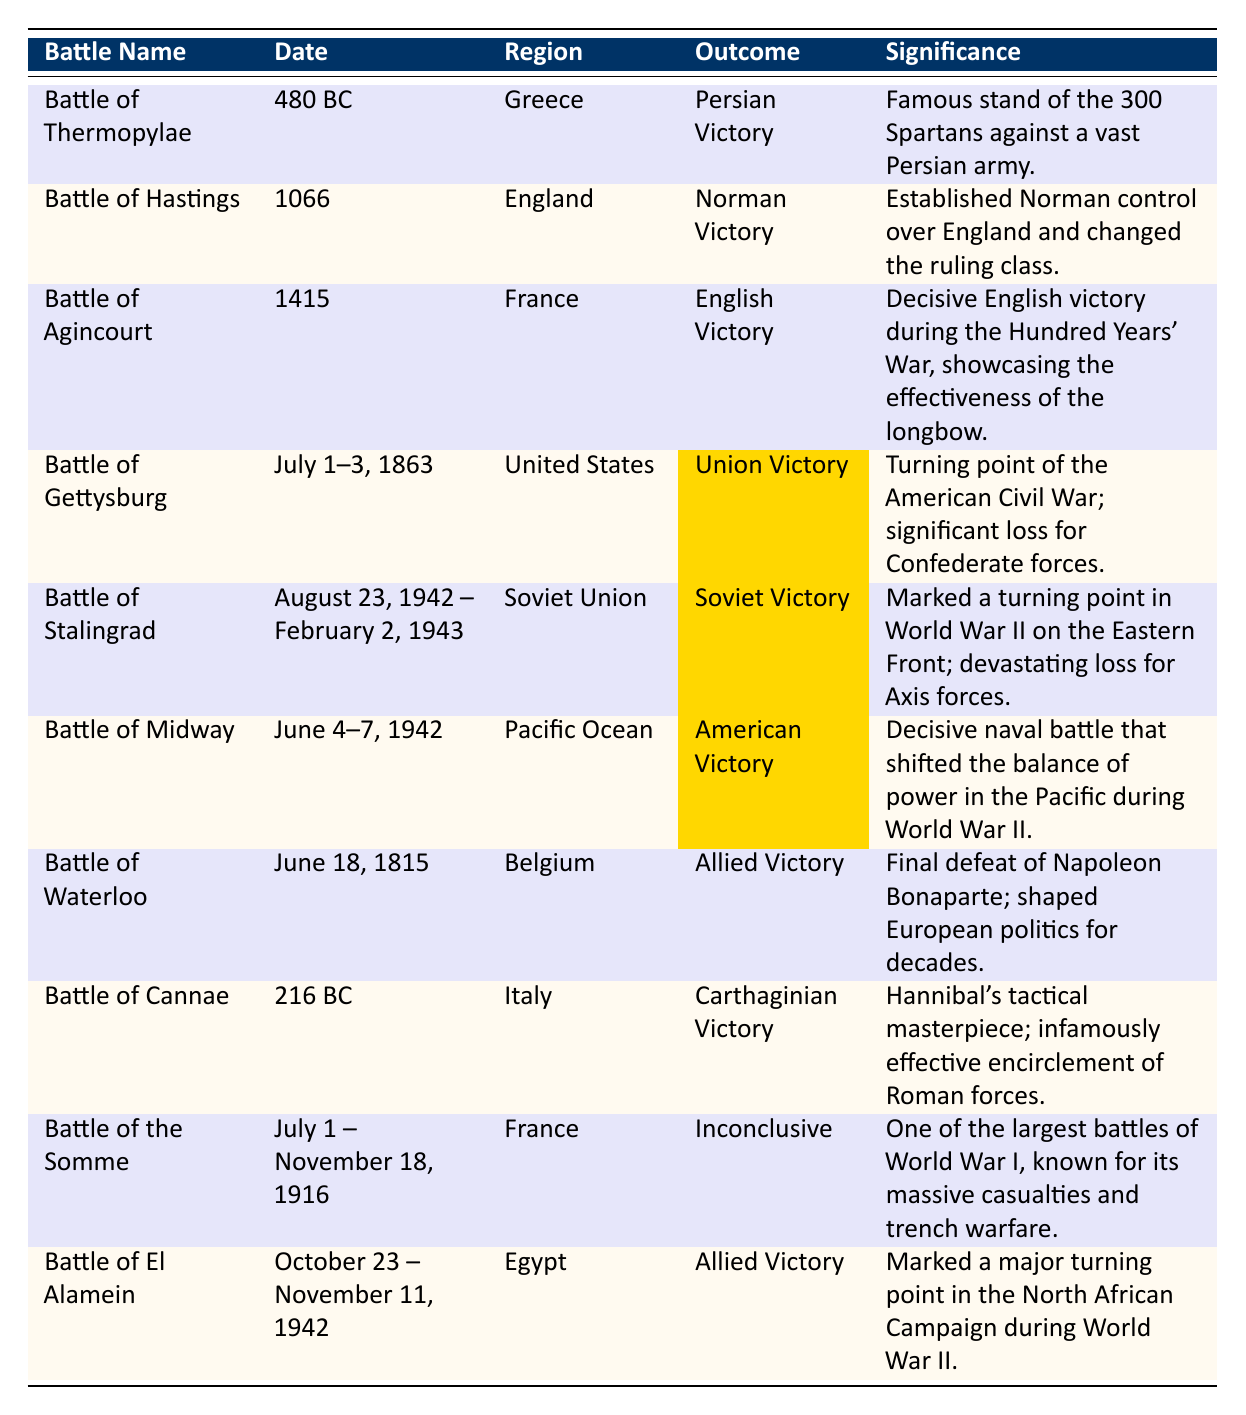What battle had the outcome of a Union Victory? The table shows several battles, and by looking under the "Outcome" column, we can identify that the "Battle of Gettysburg" had the outcome of a Union Victory.
Answer: Battle of Gettysburg Which battle occurred in 1943 and was a Soviet Victory? By examining the "Date" and "Outcome" columns, we see that the "Battle of Stalingrad" took place from August 23, 1942, to February 2, 1943, and is noted as a Soviet Victory.
Answer: Battle of Stalingrad What was the significance of the Battle of Waterloo? The significance of the Battle of Waterloo is mentioned in the last column, which states that it was the final defeat of Napoleon Bonaparte and shaped European politics for decades.
Answer: Final defeat of Napoleon Bonaparte; shaped European politics for decades How many battles listed were won by Allied Forces? The battles with Allied victories are the Battle of Waterloo, the Battle of El Alamein, and the Battle of Midway. Counting these, there are three battles won by Allied Forces.
Answer: 3 Which battle had an outcome noted as "Inconclusive"? The table specifies that the "Battle of the Somme" had an outcome listed as Inconclusive.
Answer: Battle of the Somme Was the Battle of Cannae a victory for the Romans? From the table, we see that the Battle of Cannae resulted in a Carthaginian Victory, indicating it was not a victory for the Romans.
Answer: No In which region did the Battle of Agincourt take place? The region column reveals that the Battle of Agincourt took place in France.
Answer: France Among the battles listed, which two had outcomes indicated with highlight color? Referring to the highlight color in the "Outcome" column, the battles with highlighted outcomes are the Battle of Gettysburg (Union Victory) and the Battle of Midway (American Victory).
Answer: Battle of Gettysburg and Battle of Midway What is the date range of the Battle of El Alamein? The "Date" column of the table shows that the Battle of El Alamein occurred from October 23 to November 11, 1942.
Answer: October 23 – November 11, 1942 Which battle is regarded as a turning point in the American Civil War? The table states that the Battle of Gettysburg is the turning point of the American Civil War, as noted in its significance description.
Answer: Battle of Gettysburg How does the outcome of the Battle of Stalingrad compare to that of the Battle of Thermopylae? The Battle of Stalingrad resulted in a Soviet Victory, while the Battle of Thermopylae resulted in a Persian Victory. Therefore, they had opposing outcomes.
Answer: Opposing outcomes 